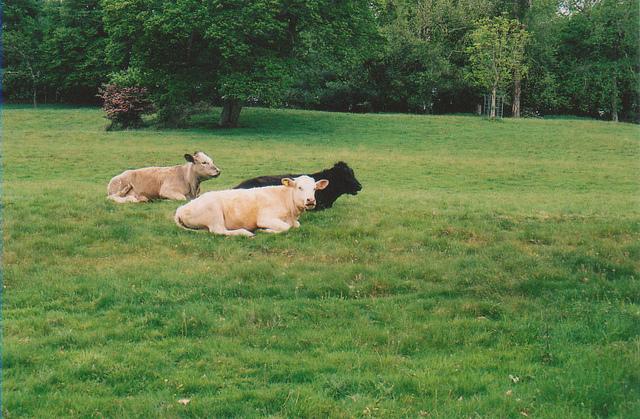How many cows are shown?
Short answer required. 3. What product does this farm produce?
Short answer required. Cows. What color is the middle cow?
Be succinct. Black. Are they sleeping?
Keep it brief. No. How many pairs of ears do you see?
Quick response, please. 3. 